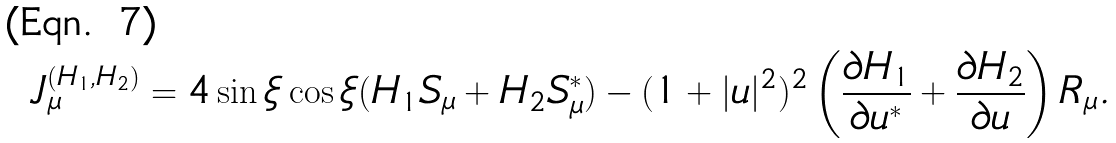<formula> <loc_0><loc_0><loc_500><loc_500>J _ { \mu } ^ { ( H _ { 1 } , H _ { 2 } ) } = 4 \sin \xi \cos \xi ( H _ { 1 } S _ { \mu } + H _ { 2 } S _ { \mu } ^ { * } ) - ( 1 + | u | ^ { 2 } ) ^ { 2 } \left ( \frac { \partial H _ { 1 } } { \partial u ^ { * } } + \frac { \partial H _ { 2 } } { \partial u } \right ) R _ { \mu } .</formula> 